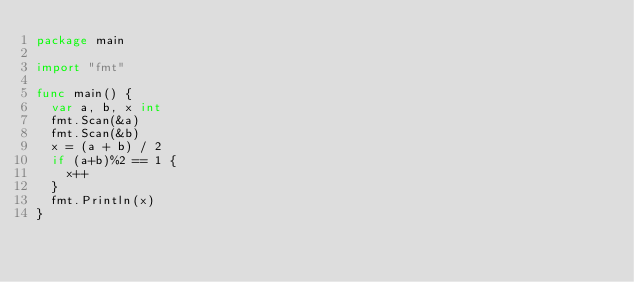<code> <loc_0><loc_0><loc_500><loc_500><_Go_>package main

import "fmt"

func main() {
	var a, b, x int
	fmt.Scan(&a)
	fmt.Scan(&b)
	x = (a + b) / 2
	if (a+b)%2 == 1 {
		x++
	}
	fmt.Println(x)
}</code> 